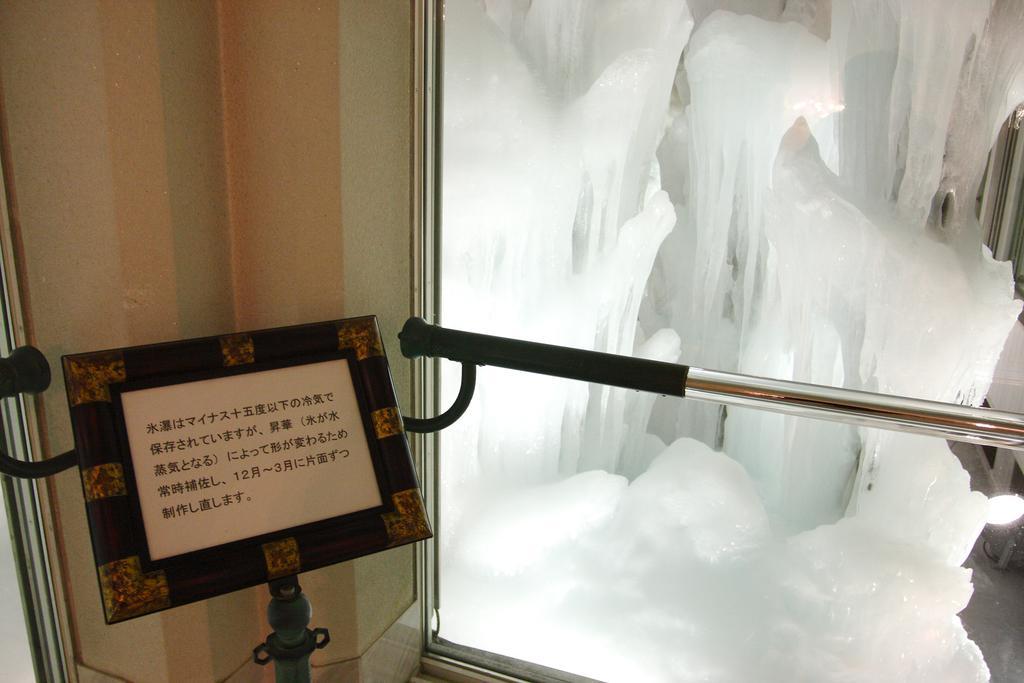In one or two sentences, can you explain what this image depicts? On the right side of this image I can see a metal stand and ice. On the left side there is a board on which I can see some text. In the background there is a wall. 